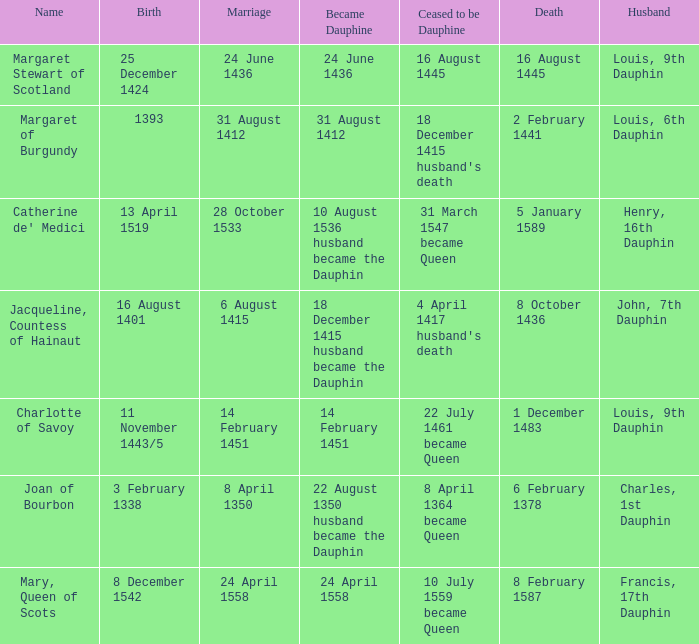When was the death of the person with husband charles, 1st dauphin? 6 February 1378. 